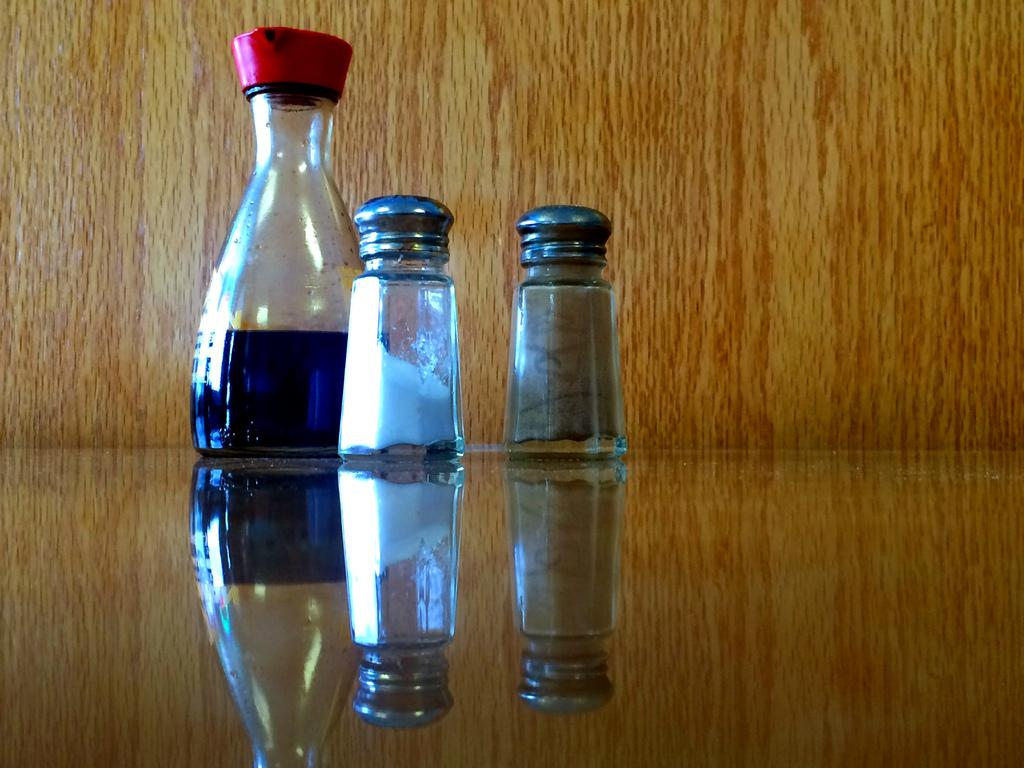What is present in the image that can hold liquids? There is a bottle in the image that can hold liquids. What else in the image can hold items? There are containers in the image that can hold items. Where are the containers and bottle located in the image? The containers and bottle are placed on a surface in the image. What can be seen in the background of the image? There is a wooden wall in the background of the image. What type of poison is being stored in the sock in the image? There is no sock or poison present in the image. 